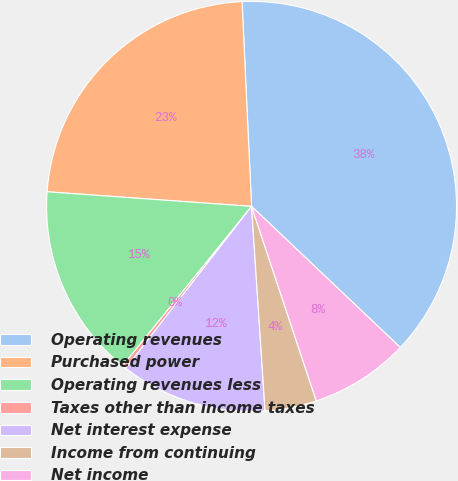Convert chart to OTSL. <chart><loc_0><loc_0><loc_500><loc_500><pie_chart><fcel>Operating revenues<fcel>Purchased power<fcel>Operating revenues less<fcel>Taxes other than income taxes<fcel>Net interest expense<fcel>Income from continuing<fcel>Net income<nl><fcel>37.81%<fcel>23.12%<fcel>15.31%<fcel>0.31%<fcel>11.56%<fcel>4.06%<fcel>7.81%<nl></chart> 